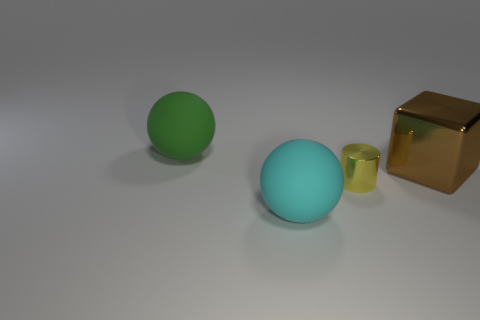What is the material of the thing that is in front of the yellow thing?
Your response must be concise. Rubber. How many yellow metal objects are the same shape as the brown object?
Give a very brief answer. 0. The other thing that is made of the same material as the brown thing is what shape?
Offer a terse response. Cylinder. What shape is the large object that is to the right of the rubber thing that is in front of the big object that is right of the small yellow cylinder?
Offer a terse response. Cube. Are there more yellow shiny objects than blue metallic things?
Keep it short and to the point. Yes. What material is the other large object that is the same shape as the green rubber thing?
Your answer should be very brief. Rubber. Is the material of the brown thing the same as the cylinder?
Your response must be concise. Yes. Is the number of big matte objects left of the cyan thing greater than the number of small red matte cylinders?
Your answer should be very brief. Yes. What is the material of the ball to the right of the matte ball to the left of the matte object in front of the large green matte sphere?
Ensure brevity in your answer.  Rubber. How many objects are either green balls or things that are on the right side of the big green thing?
Ensure brevity in your answer.  4. 